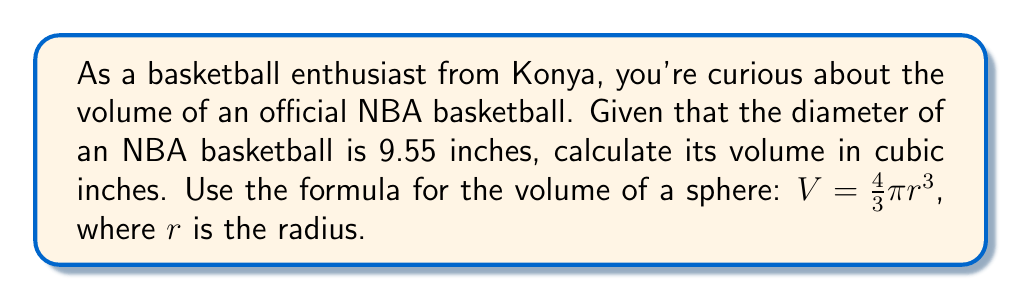Give your solution to this math problem. Let's approach this step-by-step:

1) First, we need to find the radius of the basketball. We're given the diameter, which is 9.55 inches.
   Radius is half of the diameter:
   $r = \frac{9.55}{2} = 4.775$ inches

2) Now we can use the formula for the volume of a sphere:
   $V = \frac{4}{3}\pi r^3$

3) Let's substitute our radius value:
   $V = \frac{4}{3}\pi (4.775)^3$

4) Calculate the cube of the radius:
   $(4.775)^3 = 108.7404296875$

5) Now our equation looks like this:
   $V = \frac{4}{3}\pi (108.7404296875)$

6) Multiply by $\frac{4}{3}$:
   $V = 4.188790204916667\pi$

7) Multiply by $\pi$ (we'll use 3.14159265359 for $\pi$):
   $V = 4.188790204916667 * 3.14159265359 = 13.1591693665513$

8) Round to two decimal places:
   $V \approx 13.16$ cubic inches

Therefore, the volume of an NBA basketball is approximately 13.16 cubic inches.
Answer: $13.16$ cubic inches 